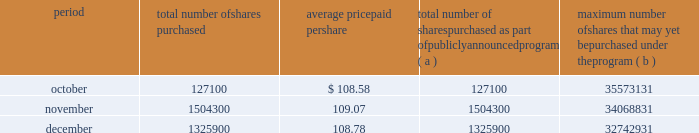Issuer purchases of equity securities the table provides information about our repurchases of common stock during the three-month period ended december 31 , 2007 .
Period total number of shares purchased average price paid per total number of shares purchased as part of publicly announced program ( a ) maximum number of shares that may yet be purchased under the program ( b ) .
( a ) we repurchased a total of 2957300 shares of our common stock during the quarter ended december 31 , 2007 under a share repurchase program that we announced in october 2002 .
( b ) our board of directors has approved a share repurchase program for the repurchase of up to 128 million shares of our common stock from time-to-time , including 20 million shares approved for repurchase by our board of directors in september 2007 .
Under the program , management has discretion to determine the number and price of the shares to be repurchased , and the timing of any repurchases , in compliance with applicable law and regulation .
As of december 31 , 2007 , we had repurchased a total of 95.3 million shares under the program .
In 2007 , we did not make any unregistered sales of equity securities. .
How many shares in millions are available to be repurchased under the approved share repurchase program? 
Computations: (128 - 95.3)
Answer: 32.7. 